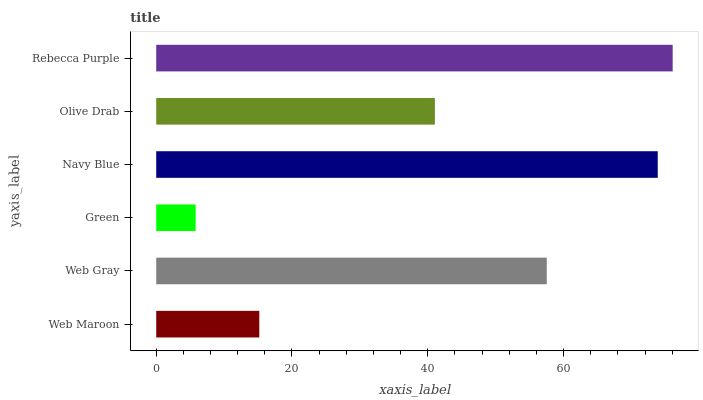Is Green the minimum?
Answer yes or no. Yes. Is Rebecca Purple the maximum?
Answer yes or no. Yes. Is Web Gray the minimum?
Answer yes or no. No. Is Web Gray the maximum?
Answer yes or no. No. Is Web Gray greater than Web Maroon?
Answer yes or no. Yes. Is Web Maroon less than Web Gray?
Answer yes or no. Yes. Is Web Maroon greater than Web Gray?
Answer yes or no. No. Is Web Gray less than Web Maroon?
Answer yes or no. No. Is Web Gray the high median?
Answer yes or no. Yes. Is Olive Drab the low median?
Answer yes or no. Yes. Is Rebecca Purple the high median?
Answer yes or no. No. Is Rebecca Purple the low median?
Answer yes or no. No. 